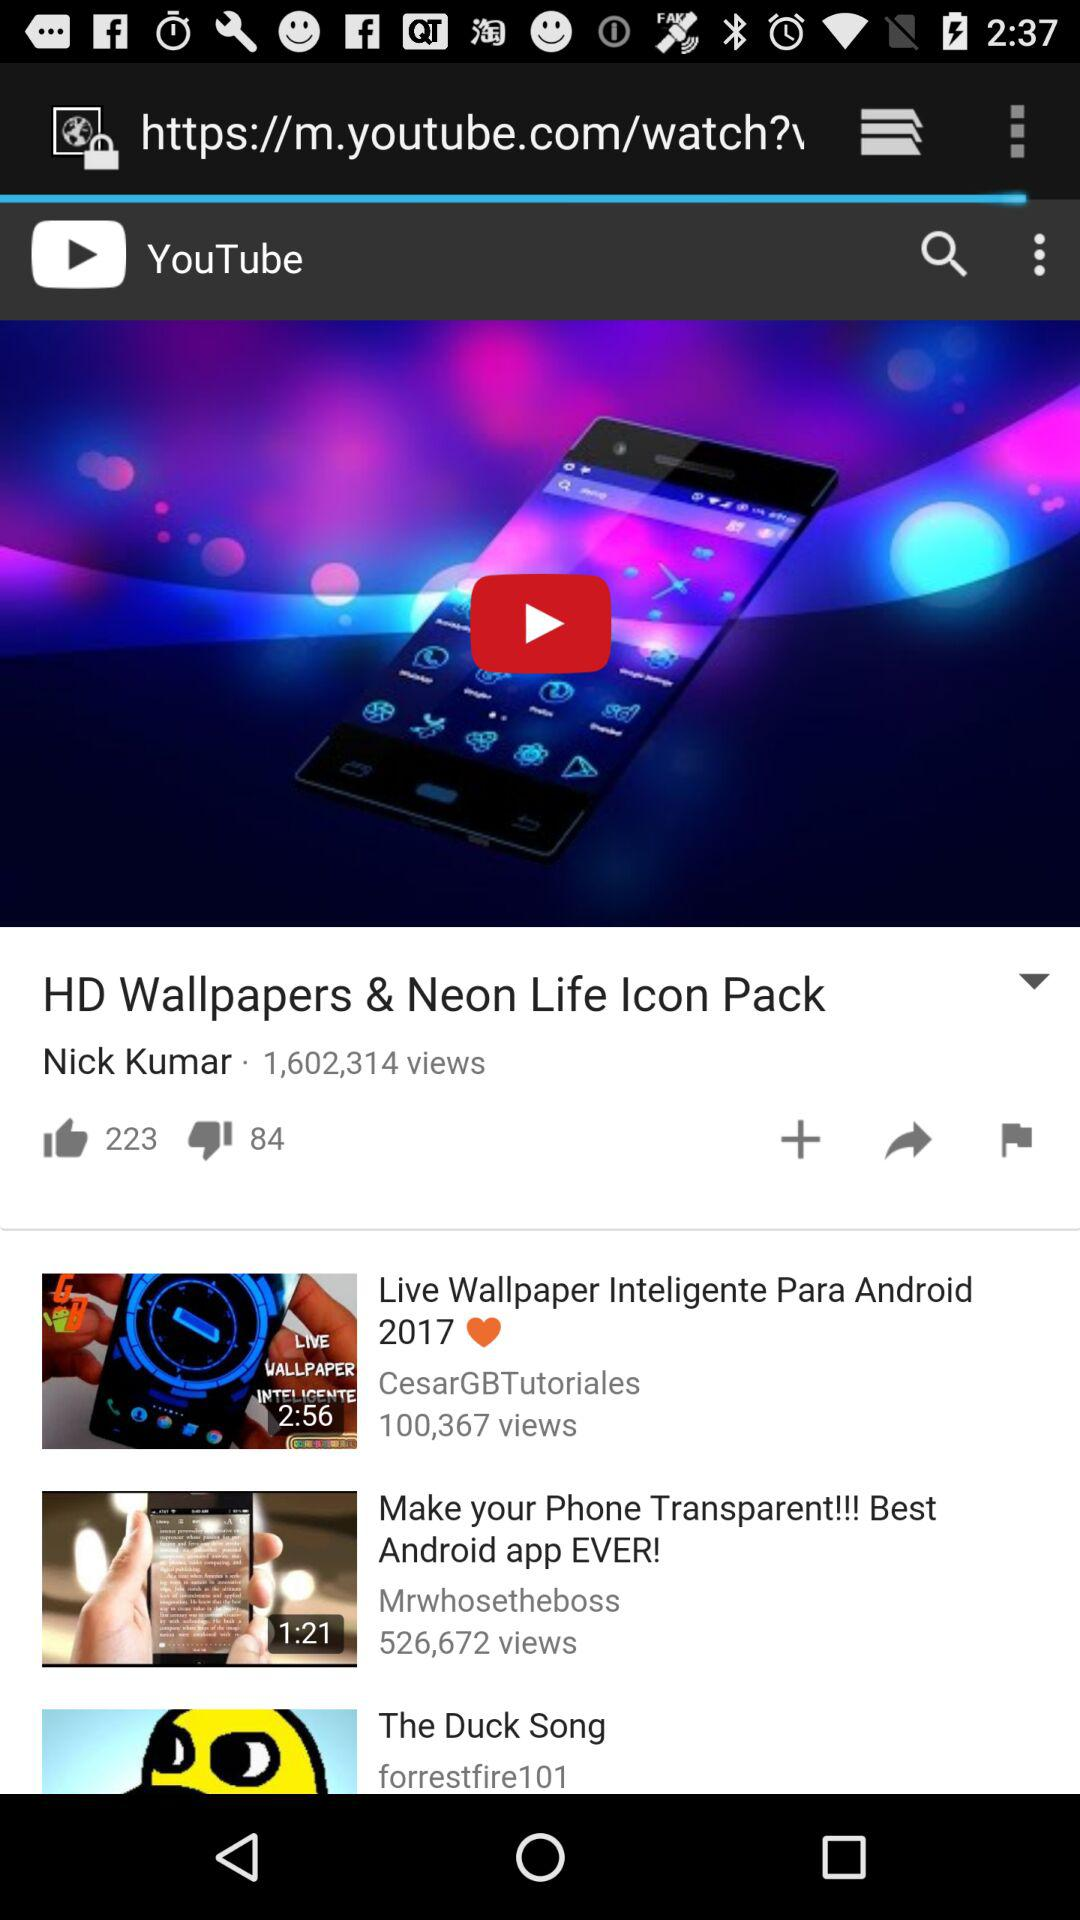Can we add the video?
When the provided information is insufficient, respond with <no answer>. <no answer> 